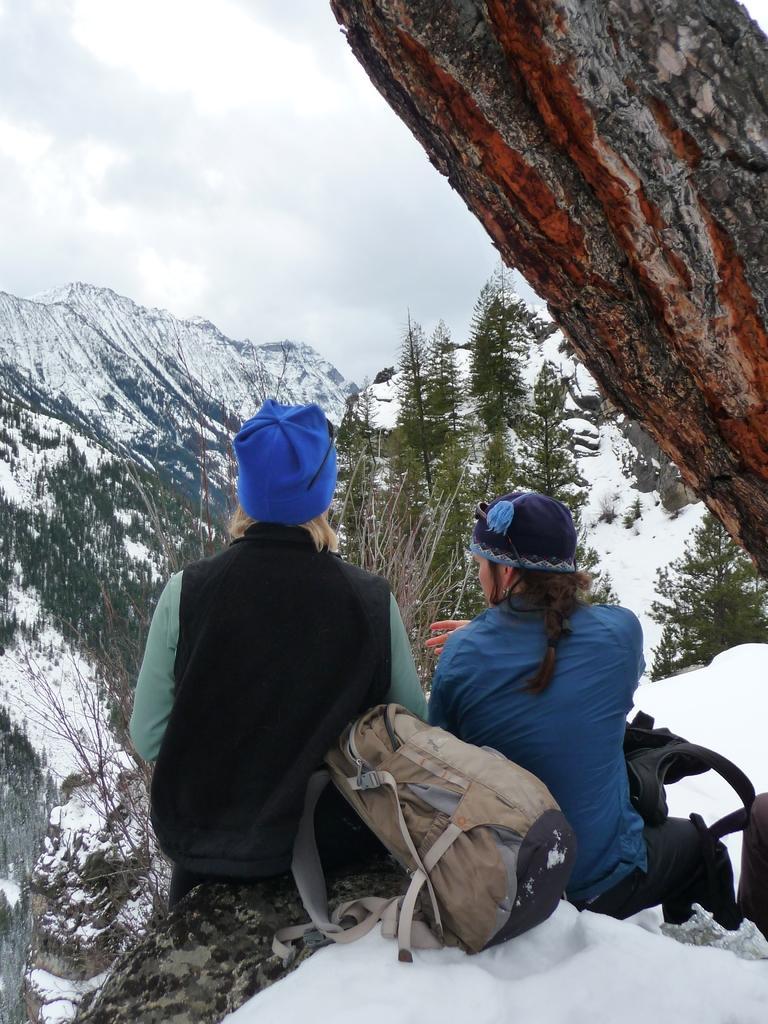Please provide a concise description of this image. In this image I see 2 persons who are sitting and they are wearing caps, I can also see bags near to them and I see the snow over here. In the background I see the mountains, trees and the sky. 